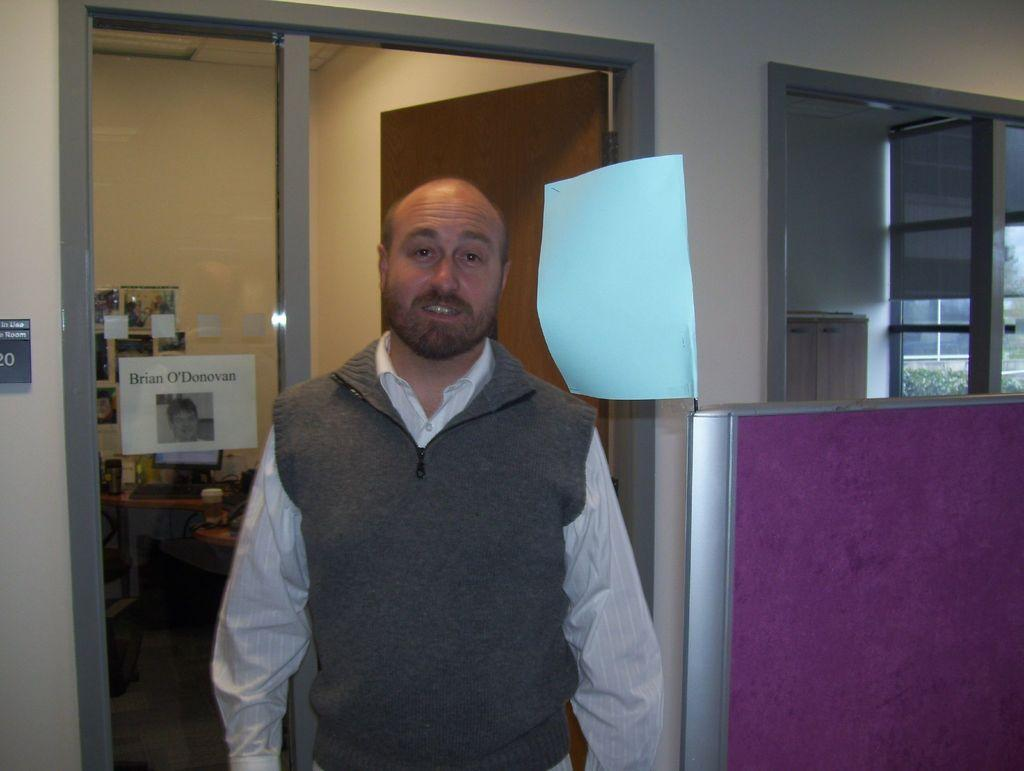Who is the main subject in the image? There is a man standing in the center of the image. What can be seen in the background of the image? There is a room, a door, and a wall visible in the background. Can you describe the setting of the image? The image appears to be set in a room, with a man standing in the center and a door and wall visible in the background. What type of produce is the man holding in the image? There is no produce visible in the image; the man is not holding anything. 